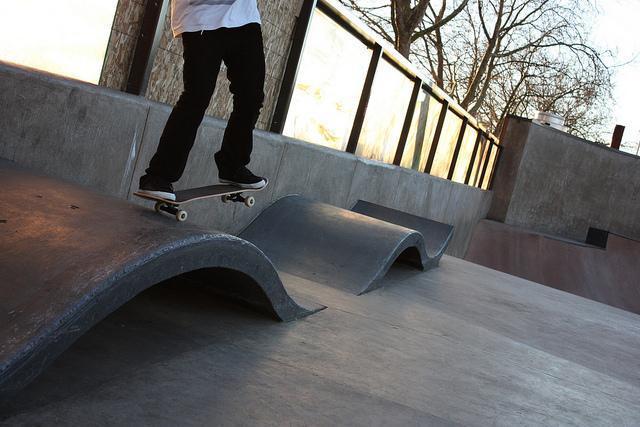How many people are visible?
Give a very brief answer. 1. How many open umbrellas are there?
Give a very brief answer. 0. 